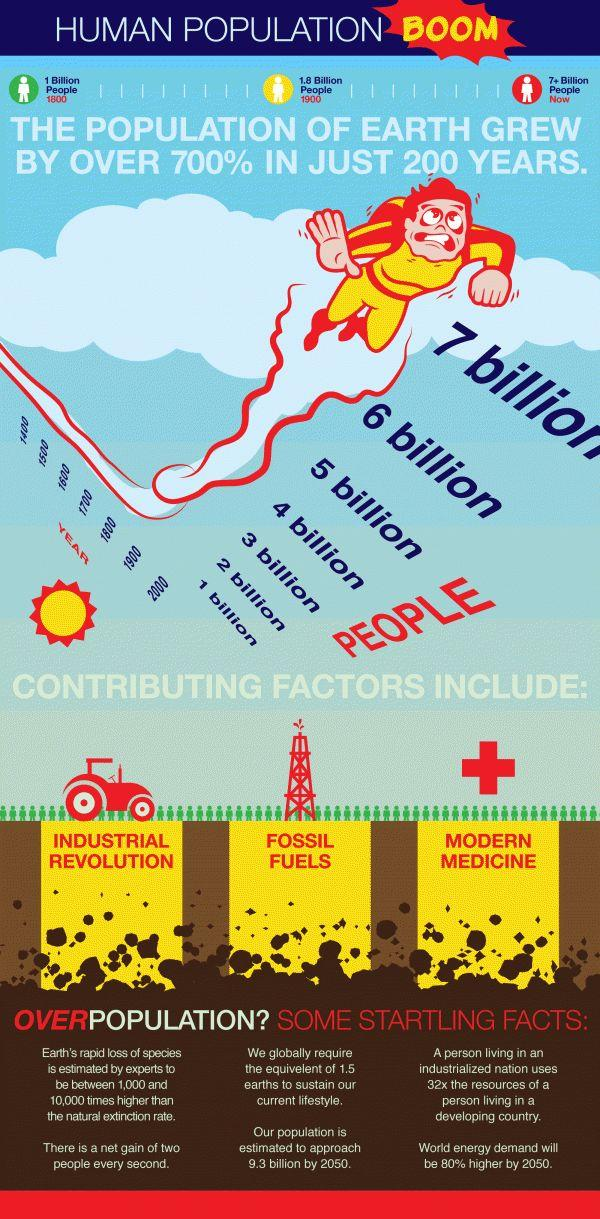Indicate a few pertinent items in this graphic. The rapid growth of the human population is the result of various factors, including the Industrial Revolution, the exploitation of fossil fuels, and the advancements in modern medicine. The human population is influenced by three factors: birth rates, death rates, and migration. 